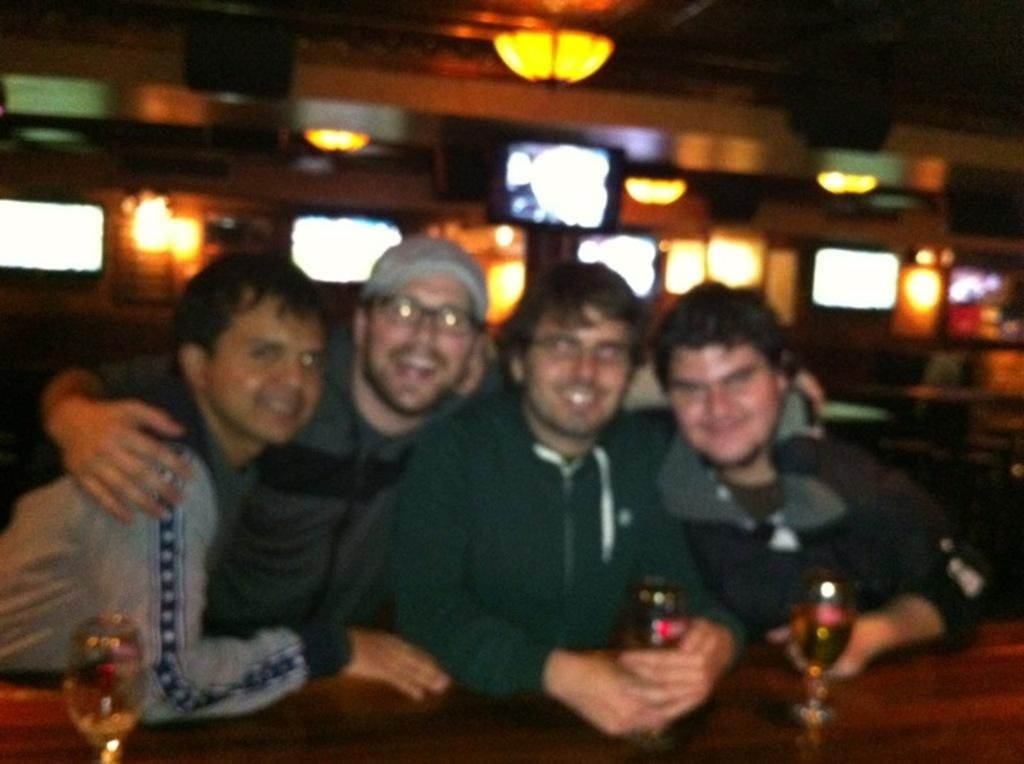How many people are present in the image? There are four people in the image. What are the people doing in the image? The people are having a drink. What can be seen in the background of the image? There is a television and a roof with lighting arrangement in the background of the image. What type of pump is visible in the image? There is no pump present in the image. Is there a crown on the head of any person in the image? No, there is no crown on the head of any person in the image. 